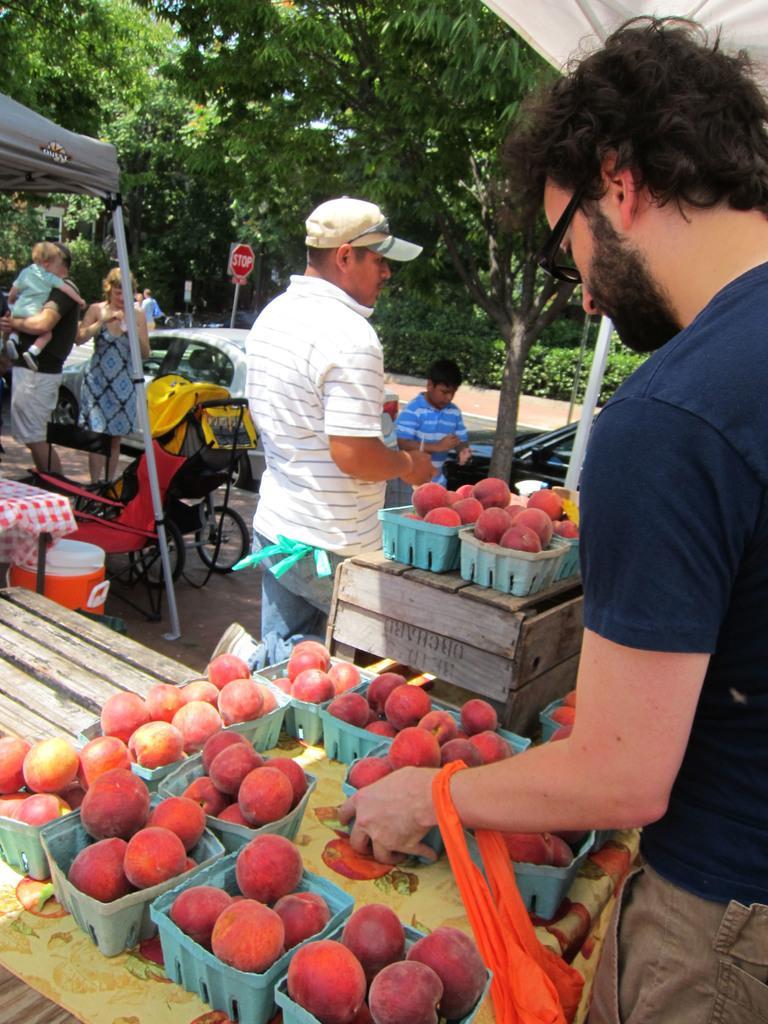In one or two sentences, can you explain what this image depicts? In this image in the front there are fruits in the basket which is on the table and on the right side there is a man standing. In the center there are persons standing, there is a car, there is a bicycle. In the background there are trees and plants. 